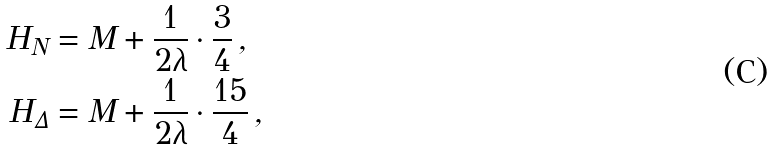<formula> <loc_0><loc_0><loc_500><loc_500>H _ { N } & = M + \frac { 1 } { 2 \lambda } \cdot \frac { 3 } { 4 } \, , \\ H _ { \Delta } & = M + \frac { 1 } { 2 \lambda } \cdot \frac { 1 5 } { 4 } \, ,</formula> 